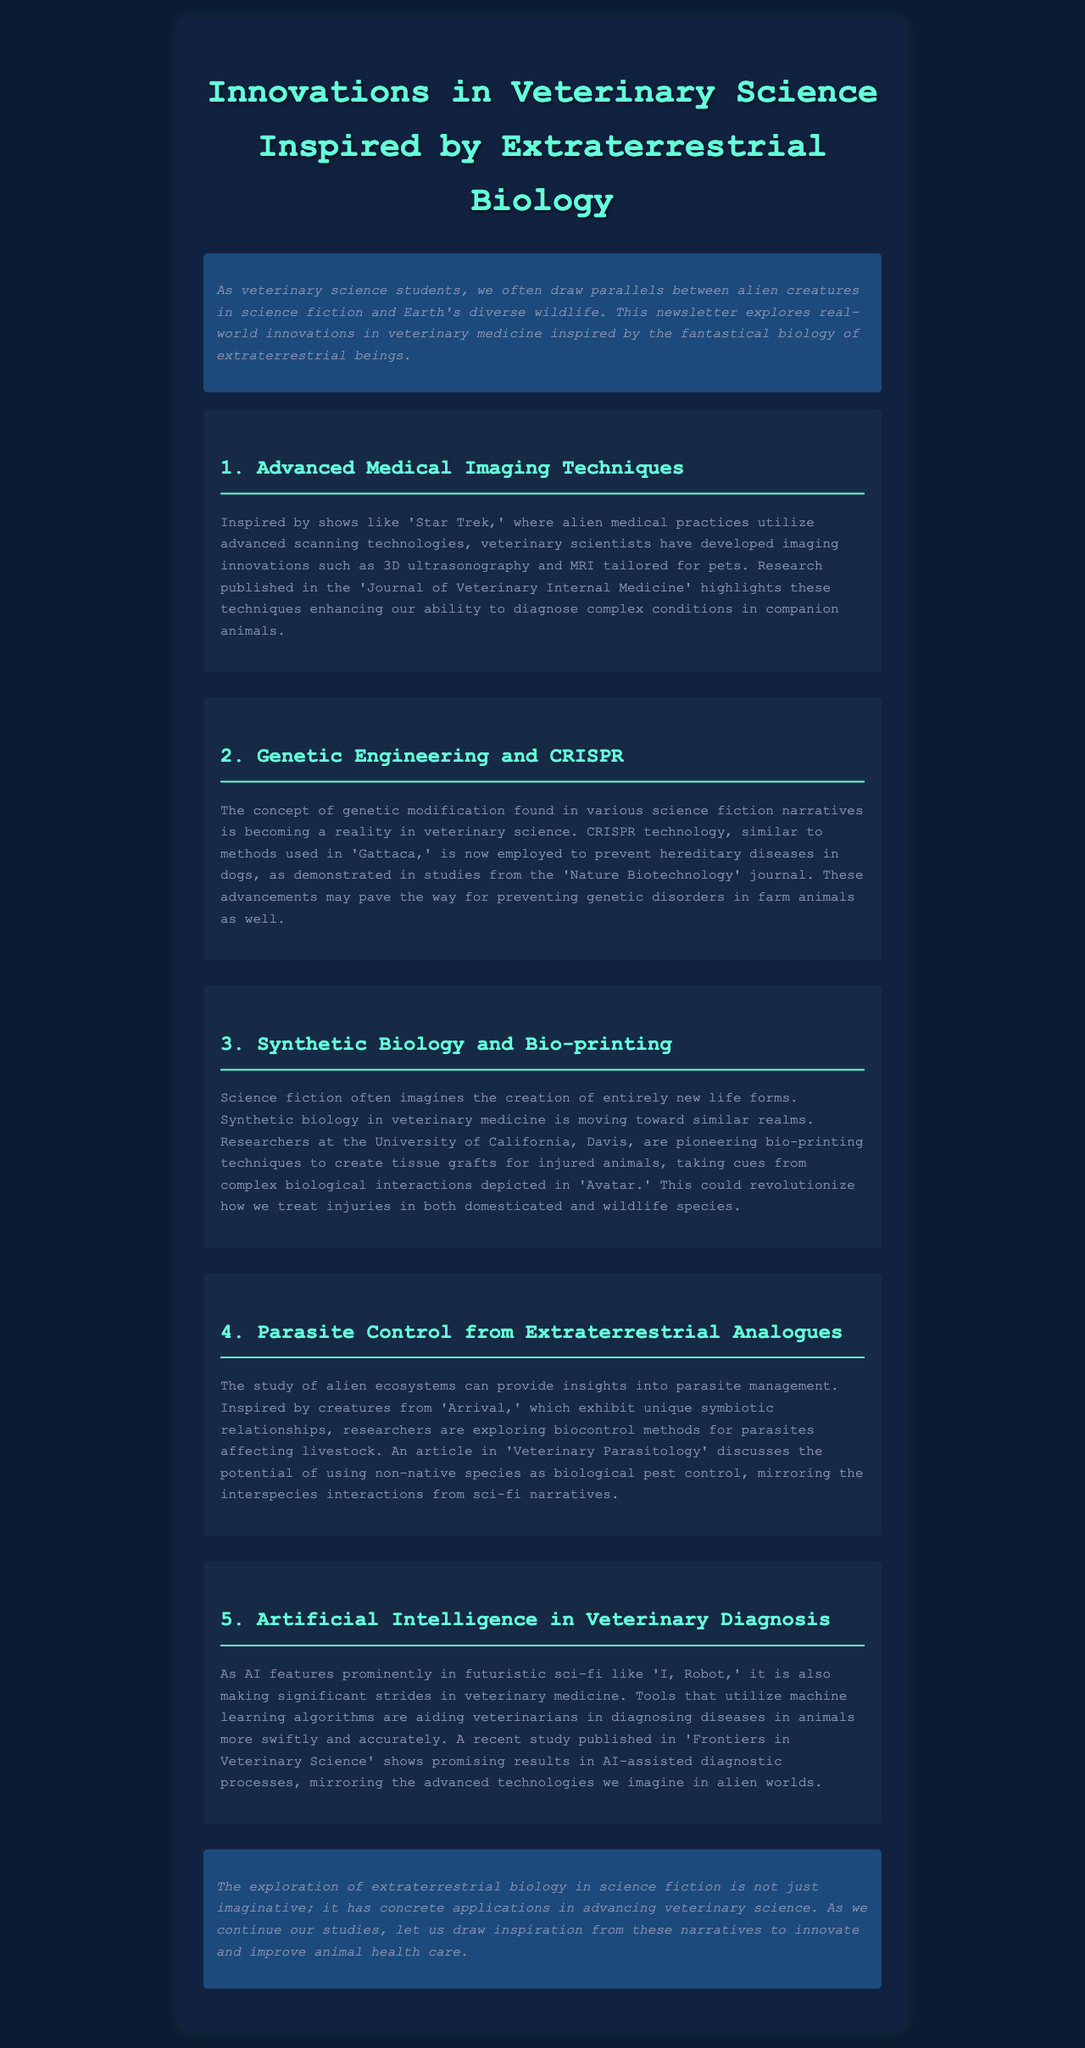what are the advanced imaging techniques mentioned? The document discusses 3D ultrasonography and MRI as advanced imaging techniques tailored for pets.
Answer: 3D ultrasonography and MRI which science fiction show inspired advanced medical imaging? The newsletter references 'Star Trek' as a source of inspiration for advanced medical imaging techniques in veterinary science.
Answer: Star Trek what technology is used to prevent hereditary diseases in dogs? The document mentions CRISPR technology as a method to prevent hereditary diseases in canines.
Answer: CRISPR what is being pioneered at the University of California, Davis? Researchers at the University of California, Davis, are pioneering bio-printing techniques to create tissue grafts for injured animals.
Answer: Bio-printing techniques which publication discussed biocontrol methods for parasites? The article in 'Veterinary Parasitology' addresses the potential of using non-native species for biocontrol methods.
Answer: Veterinary Parasitology what concept is explored in regard to parasite management? The document describes how insights from alien ecosystems are being explored for parasite management in livestock.
Answer: Alien ecosystems which tool aids veterinarians in diagnosing diseases? The newsletter states that machine learning algorithms are tools aiding veterinarians in diagnosis.
Answer: Machine learning algorithms what advanced technology is reflected in the AI-assisted diagnostic processes? The document highlights that AI features prominently in futuristic science fiction and is making strides in veterinary medicine diagnostic processes.
Answer: AI what lesson does the conclusion encourage veterinary science students to draw? It encourages students to draw inspiration from narratives of extraterrestrial biology in science fiction to innovate in veterinary medicine.
Answer: Inspire from narratives 